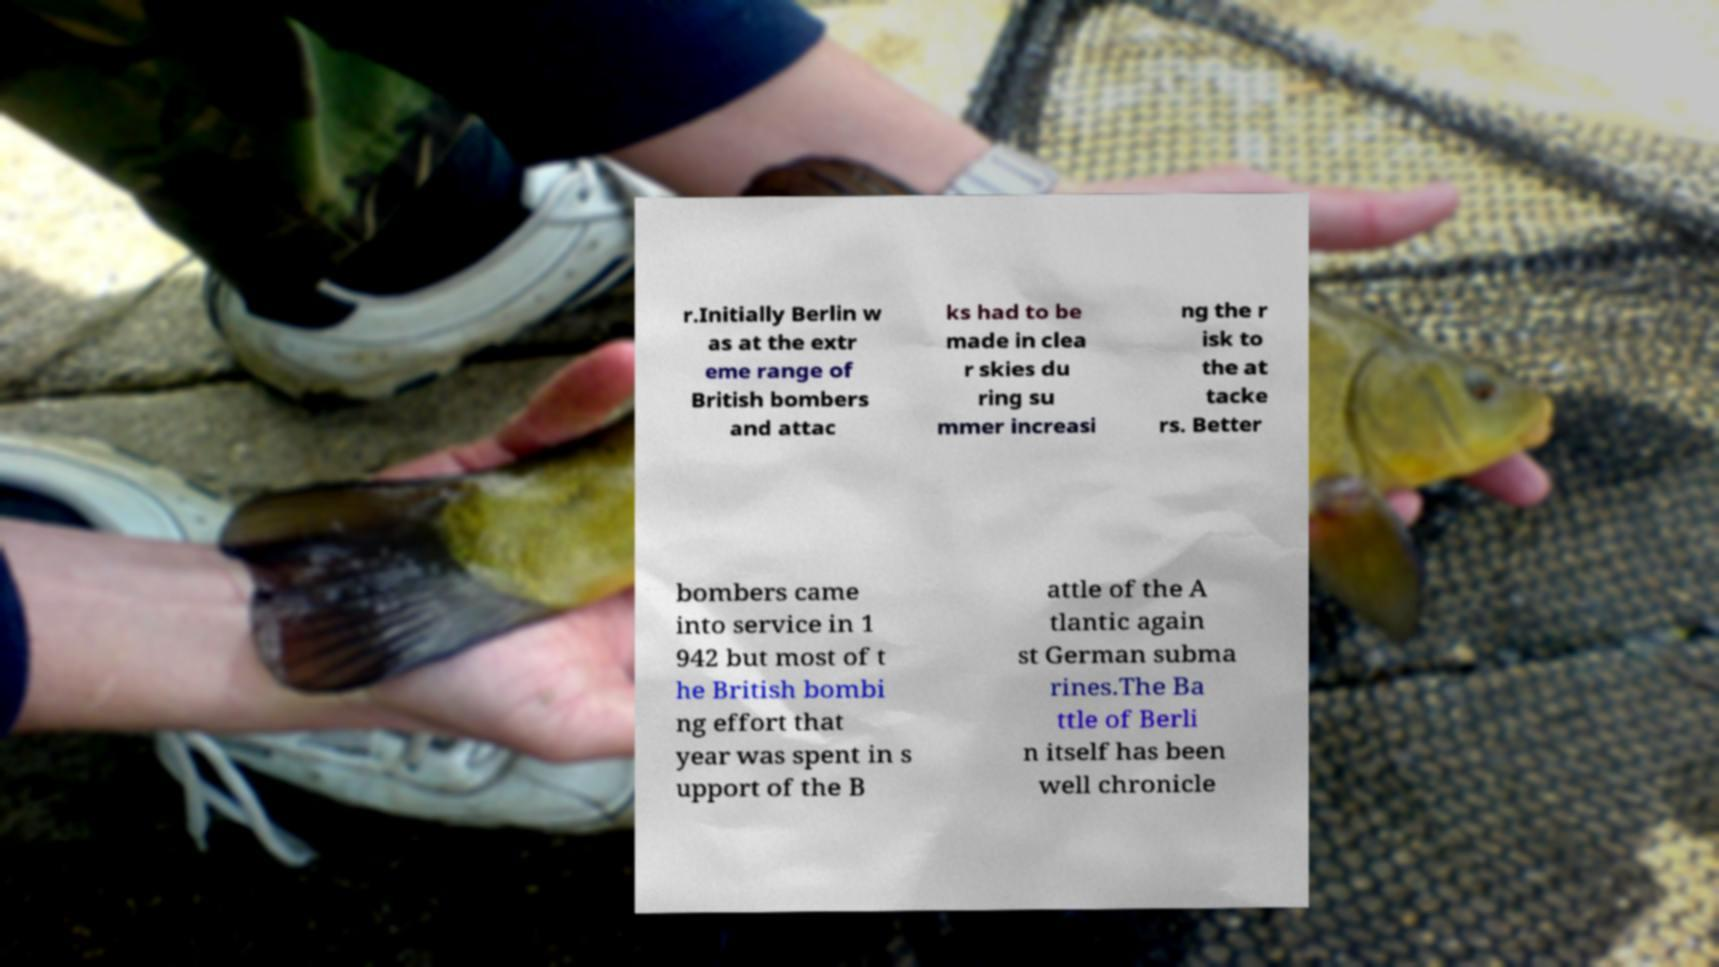Can you accurately transcribe the text from the provided image for me? r.Initially Berlin w as at the extr eme range of British bombers and attac ks had to be made in clea r skies du ring su mmer increasi ng the r isk to the at tacke rs. Better bombers came into service in 1 942 but most of t he British bombi ng effort that year was spent in s upport of the B attle of the A tlantic again st German subma rines.The Ba ttle of Berli n itself has been well chronicle 